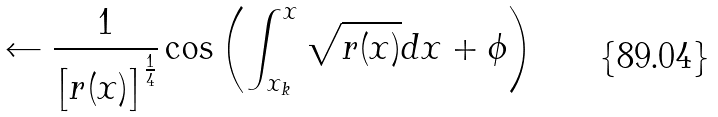Convert formula to latex. <formula><loc_0><loc_0><loc_500><loc_500>\leftarrow \frac { 1 } { \left [ r ( x ) \right ] ^ { \frac { 1 } { 4 } } } \cos \left ( \int _ { x _ { k } } ^ { x } \sqrt { r ( x ) } d x + \phi \right )</formula> 